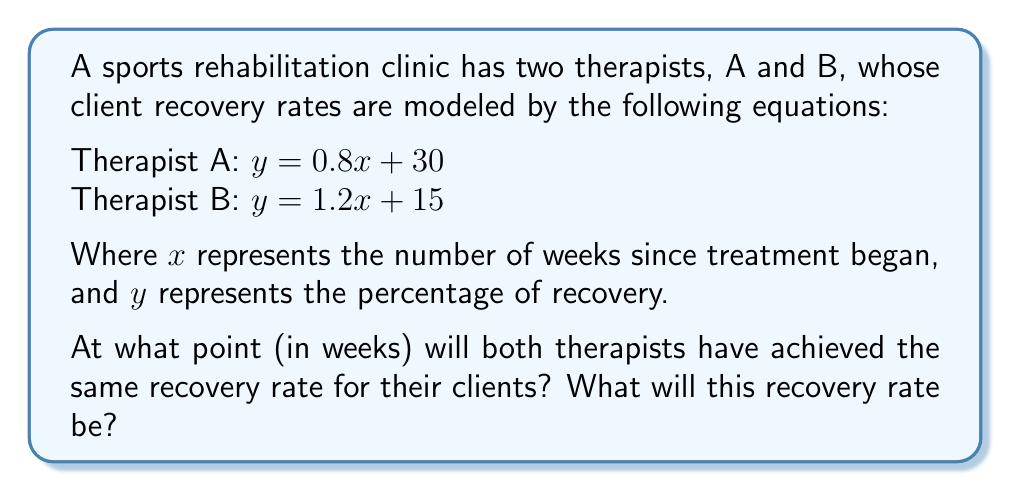What is the answer to this math problem? To solve this problem, we need to find the intersection point of the two lines representing the therapists' recovery rates. This can be done using the following steps:

1) Set the equations equal to each other:
   $0.8x + 30 = 1.2x + 15$

2) Subtract $0.8x$ from both sides:
   $30 = 0.4x + 15$

3) Subtract 15 from both sides:
   $15 = 0.4x$

4) Divide both sides by 0.4:
   $\frac{15}{0.4} = x$
   $37.5 = x$

5) Now that we know the x-coordinate (weeks), we can substitute this value into either of the original equations to find the y-coordinate (recovery rate). Let's use Therapist A's equation:

   $y = 0.8(37.5) + 30$
   $y = 30 + 30 = 60$

Therefore, the therapists will achieve the same recovery rate after 37.5 weeks, and the recovery rate at this point will be 60%.
Answer: 37.5 weeks; 60% recovery rate 